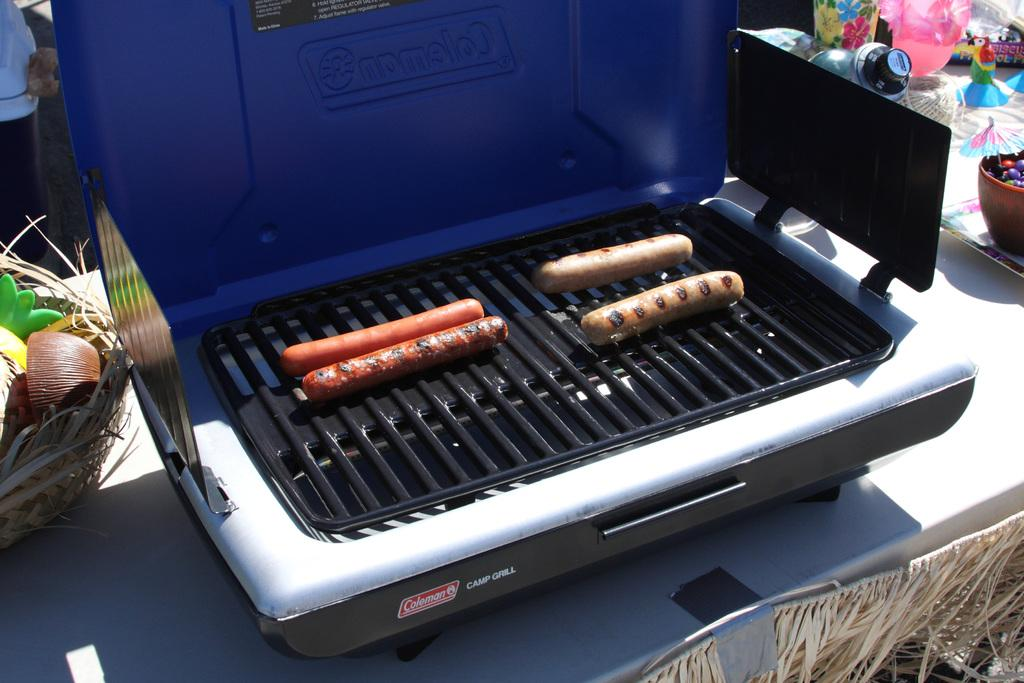<image>
Offer a succinct explanation of the picture presented. A grill with hot dogs cooking on it that says Coleman Camp Grill on it. 